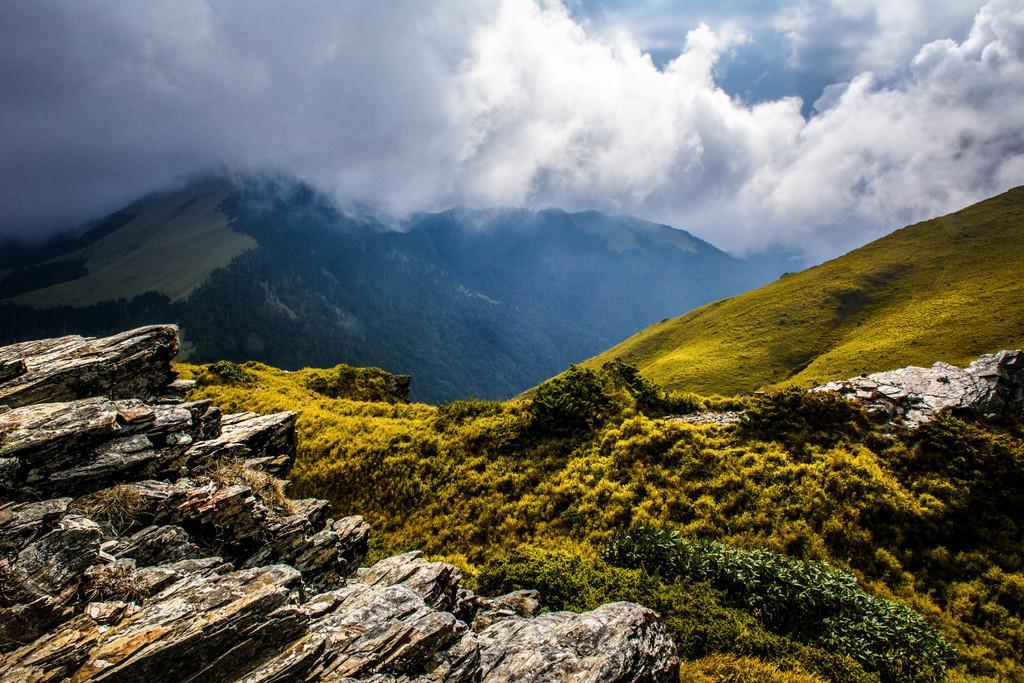Please provide a concise description of this image. In this picture we can see mountains and in the background we can see sky with clouds. 